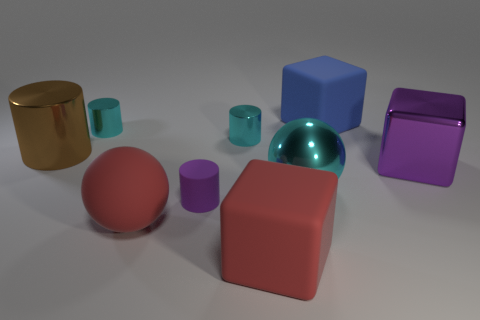Is the material of the large red ball the same as the brown thing?
Your response must be concise. No. The red matte thing that is on the right side of the matte cylinder has what shape?
Your answer should be compact. Cube. Is there a red object to the left of the tiny metallic cylinder right of the small matte cylinder?
Provide a succinct answer. Yes. Is there a blue object that has the same size as the metallic cube?
Your answer should be very brief. Yes. There is a rubber cube to the left of the blue thing; does it have the same color as the large cylinder?
Provide a short and direct response. No. What size is the blue object?
Your answer should be very brief. Large. What size is the cube on the left side of the cube that is behind the large purple object?
Provide a short and direct response. Large. What number of metallic objects are the same color as the shiny ball?
Ensure brevity in your answer.  2. What number of matte cubes are there?
Provide a short and direct response. 2. How many big red spheres are made of the same material as the purple cylinder?
Give a very brief answer. 1. 